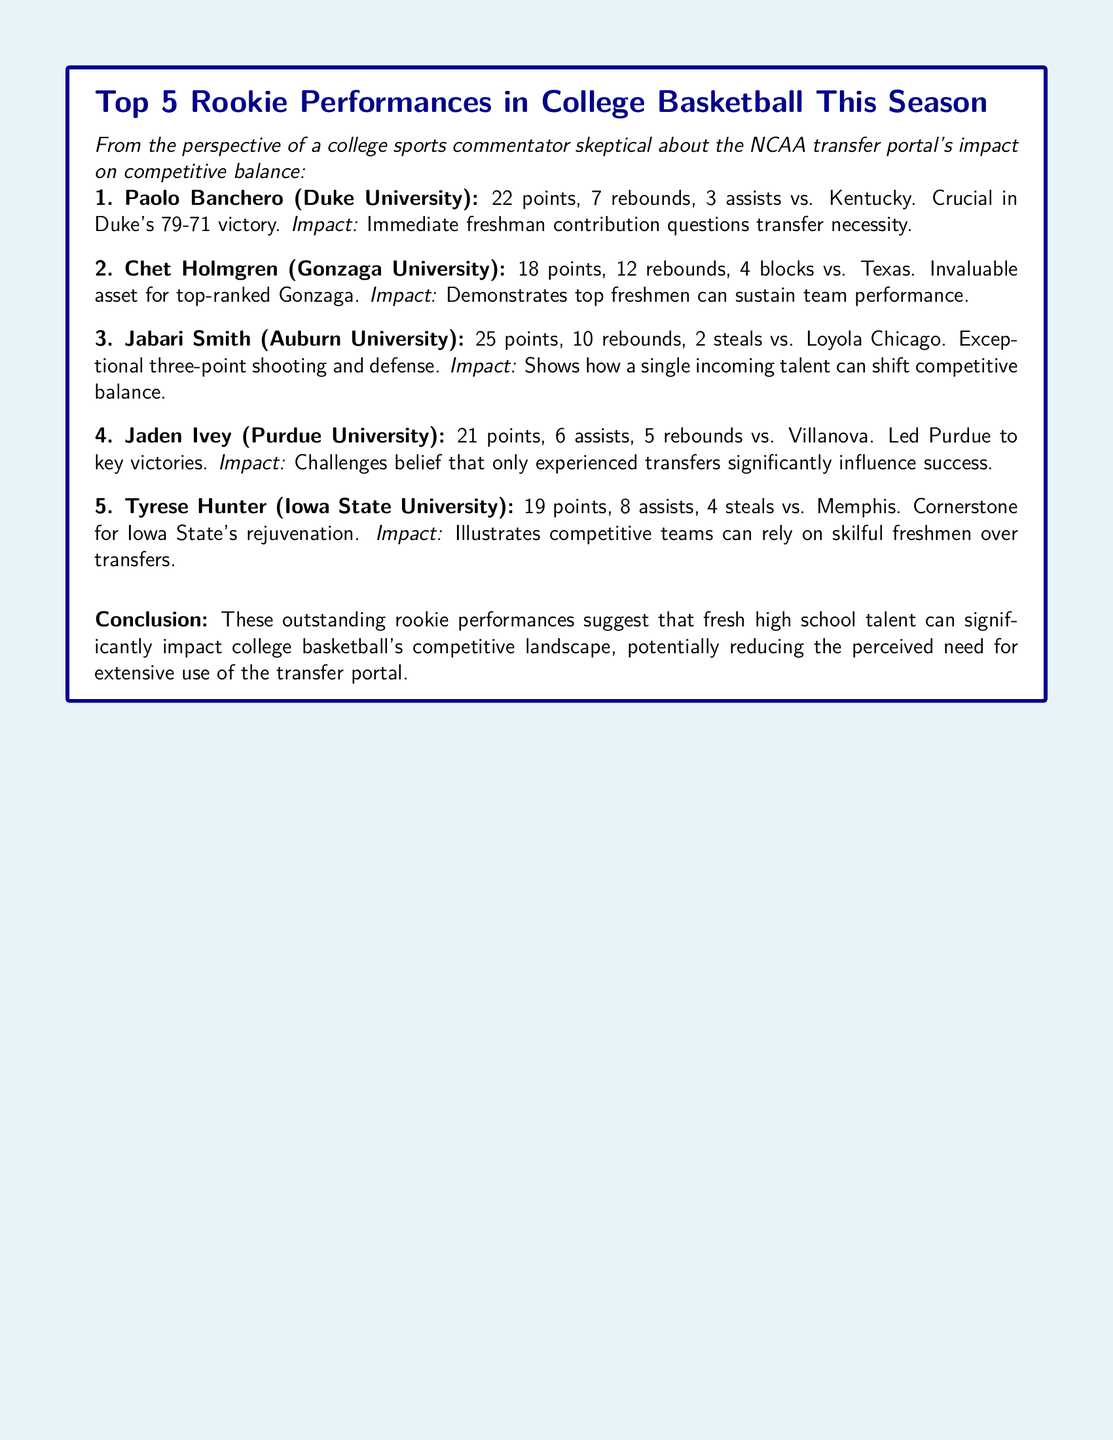What was Paolo Banchero's performance against Kentucky? The document states that Paolo Banchero scored 22 points, had 7 rebounds, and 3 assists in the game against Kentucky.
Answer: 22 points, 7 rebounds, 3 assists How many points did Jabari Smith score against Loyola Chicago? According to the document, Jabari Smith scored 25 points in the game against Loyola Chicago.
Answer: 25 points Which university does Chet Holmgren represent? The document specifies that Chet Holmgren is from Gonzaga University.
Answer: Gonzaga University What impact does Tyrese Hunter's performance illustrate? The document mentions that Tyrese Hunter's performance illustrates that competitive teams can rely on skillful freshmen over transfers.
Answer: Rely on skilled freshmen over transfers What was the concluding statement regarding rookie performances? The conclusion states that outstanding rookie performances suggest that fresh high school talent can significantly impact college basketball's competitive landscape.
Answer: Fresh high school talent can significantly impact college basketball's competitive landscape How many rebounds did Chet Holmgren achieve against Texas? According to the document, Chet Holmgren achieved 12 rebounds in the game against Texas.
Answer: 12 rebounds What common thread is evident among the impacts listed for the rookies? The impacts listed for the rookies suggest a potential reduction in the perceived need for extensive use of the transfer portal.
Answer: Reduction in perceived need for the transfer portal In which game did Jaden Ivey contribute 21 points? The document notes that Jaden Ivey contributed 21 points in the game against Villanova.
Answer: Villanova 